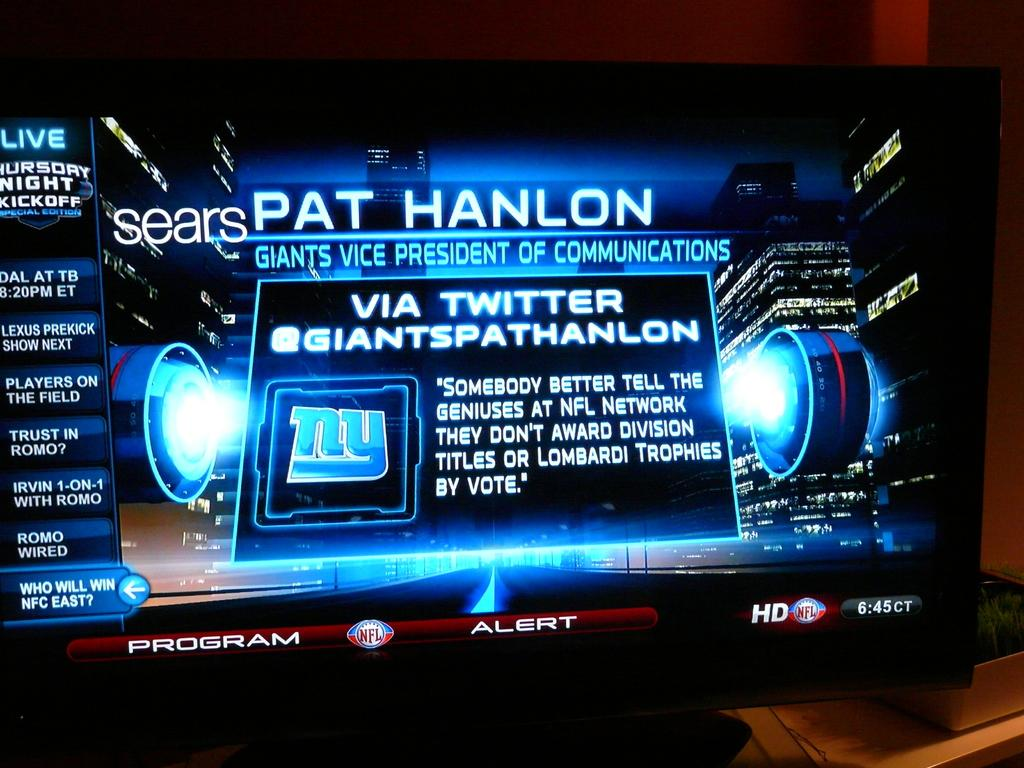<image>
Render a clear and concise summary of the photo. A neon billboard with the title Pat Hanlon Giants Vice President of Communications on it. 